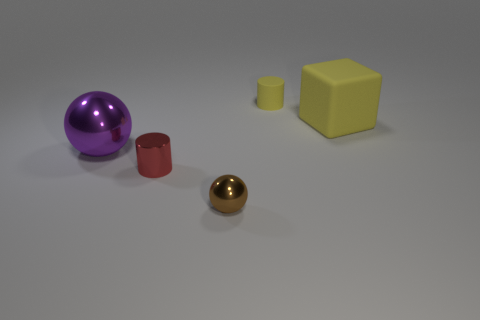Subtract all red balls. Subtract all yellow cubes. How many balls are left? 2 Add 3 balls. How many objects exist? 8 Subtract all cylinders. How many objects are left? 3 Subtract all tiny spheres. Subtract all small metal objects. How many objects are left? 2 Add 2 red cylinders. How many red cylinders are left? 3 Add 4 tiny matte spheres. How many tiny matte spheres exist? 4 Subtract 0 gray cylinders. How many objects are left? 5 